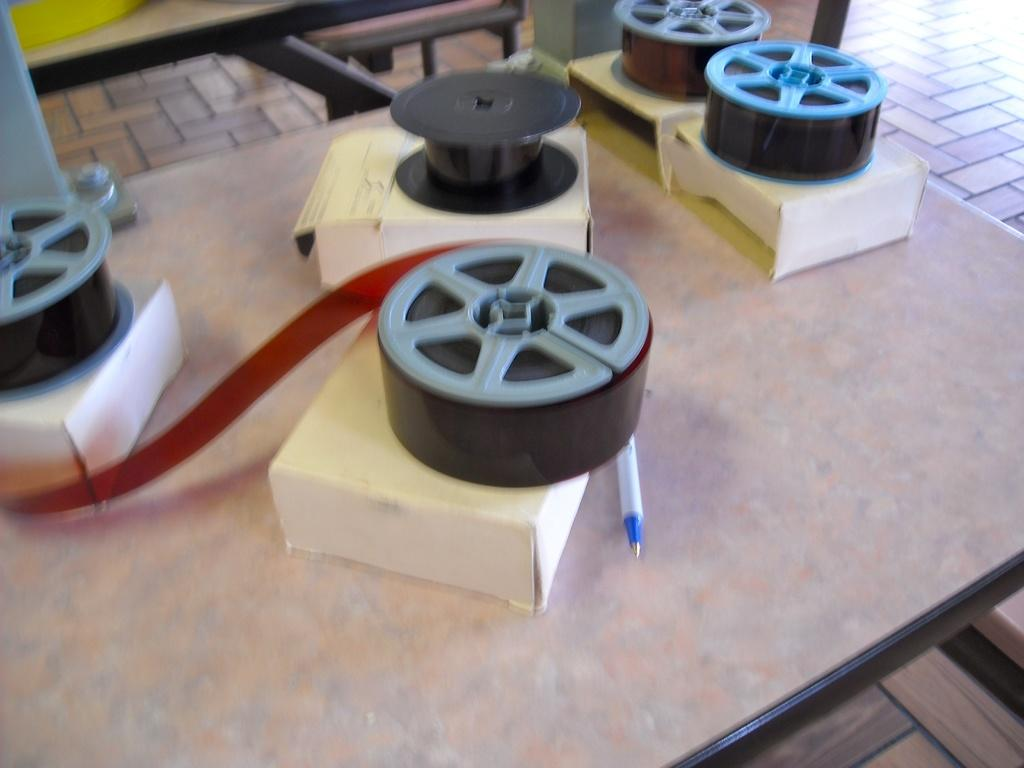What type of furniture is present in the image? There is a table in the image. What decorative items can be seen on the table? There are satin ribbons on the table. What functional items are on the table? There are cardboard cartons and a pen on the table. What songs are being sung by the dogs in the image? There are no dogs or songs present in the image. 